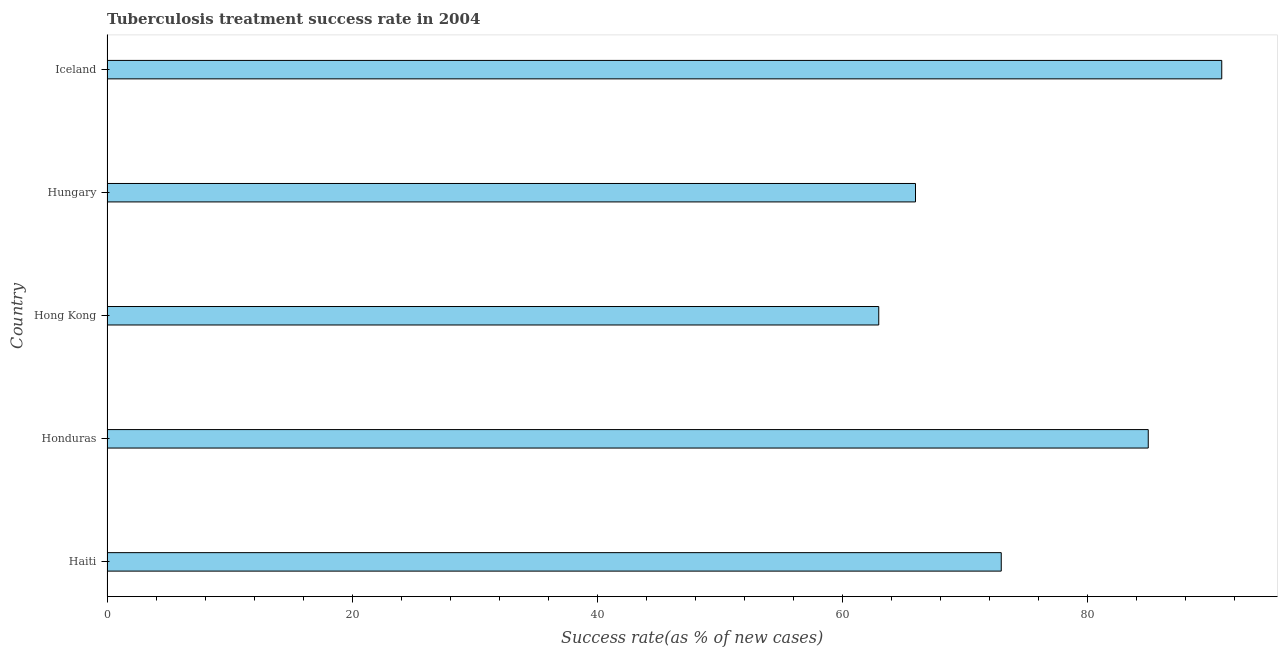Does the graph contain any zero values?
Provide a short and direct response. No. Does the graph contain grids?
Offer a very short reply. No. What is the title of the graph?
Make the answer very short. Tuberculosis treatment success rate in 2004. What is the label or title of the X-axis?
Your response must be concise. Success rate(as % of new cases). What is the label or title of the Y-axis?
Ensure brevity in your answer.  Country. Across all countries, what is the maximum tuberculosis treatment success rate?
Ensure brevity in your answer.  91. Across all countries, what is the minimum tuberculosis treatment success rate?
Offer a very short reply. 63. In which country was the tuberculosis treatment success rate maximum?
Your answer should be very brief. Iceland. In which country was the tuberculosis treatment success rate minimum?
Provide a short and direct response. Hong Kong. What is the sum of the tuberculosis treatment success rate?
Make the answer very short. 378. What is the average tuberculosis treatment success rate per country?
Offer a very short reply. 75. What is the median tuberculosis treatment success rate?
Keep it short and to the point. 73. In how many countries, is the tuberculosis treatment success rate greater than 12 %?
Offer a terse response. 5. What is the ratio of the tuberculosis treatment success rate in Haiti to that in Hong Kong?
Your answer should be compact. 1.16. Is the sum of the tuberculosis treatment success rate in Haiti and Iceland greater than the maximum tuberculosis treatment success rate across all countries?
Give a very brief answer. Yes. What is the difference between the highest and the lowest tuberculosis treatment success rate?
Offer a terse response. 28. In how many countries, is the tuberculosis treatment success rate greater than the average tuberculosis treatment success rate taken over all countries?
Make the answer very short. 2. How many bars are there?
Your answer should be very brief. 5. How many countries are there in the graph?
Your answer should be very brief. 5. What is the difference between two consecutive major ticks on the X-axis?
Offer a terse response. 20. Are the values on the major ticks of X-axis written in scientific E-notation?
Provide a short and direct response. No. What is the Success rate(as % of new cases) of Honduras?
Your answer should be very brief. 85. What is the Success rate(as % of new cases) of Hong Kong?
Make the answer very short. 63. What is the Success rate(as % of new cases) in Hungary?
Make the answer very short. 66. What is the Success rate(as % of new cases) of Iceland?
Offer a terse response. 91. What is the difference between the Success rate(as % of new cases) in Haiti and Hong Kong?
Your response must be concise. 10. What is the difference between the Success rate(as % of new cases) in Haiti and Hungary?
Your answer should be compact. 7. What is the difference between the Success rate(as % of new cases) in Haiti and Iceland?
Your answer should be compact. -18. What is the difference between the Success rate(as % of new cases) in Honduras and Hong Kong?
Offer a terse response. 22. What is the difference between the Success rate(as % of new cases) in Honduras and Hungary?
Provide a succinct answer. 19. What is the difference between the Success rate(as % of new cases) in Hong Kong and Iceland?
Give a very brief answer. -28. What is the difference between the Success rate(as % of new cases) in Hungary and Iceland?
Your response must be concise. -25. What is the ratio of the Success rate(as % of new cases) in Haiti to that in Honduras?
Provide a succinct answer. 0.86. What is the ratio of the Success rate(as % of new cases) in Haiti to that in Hong Kong?
Your answer should be compact. 1.16. What is the ratio of the Success rate(as % of new cases) in Haiti to that in Hungary?
Your response must be concise. 1.11. What is the ratio of the Success rate(as % of new cases) in Haiti to that in Iceland?
Provide a short and direct response. 0.8. What is the ratio of the Success rate(as % of new cases) in Honduras to that in Hong Kong?
Offer a very short reply. 1.35. What is the ratio of the Success rate(as % of new cases) in Honduras to that in Hungary?
Offer a terse response. 1.29. What is the ratio of the Success rate(as % of new cases) in Honduras to that in Iceland?
Offer a very short reply. 0.93. What is the ratio of the Success rate(as % of new cases) in Hong Kong to that in Hungary?
Offer a very short reply. 0.95. What is the ratio of the Success rate(as % of new cases) in Hong Kong to that in Iceland?
Your answer should be very brief. 0.69. What is the ratio of the Success rate(as % of new cases) in Hungary to that in Iceland?
Give a very brief answer. 0.72. 